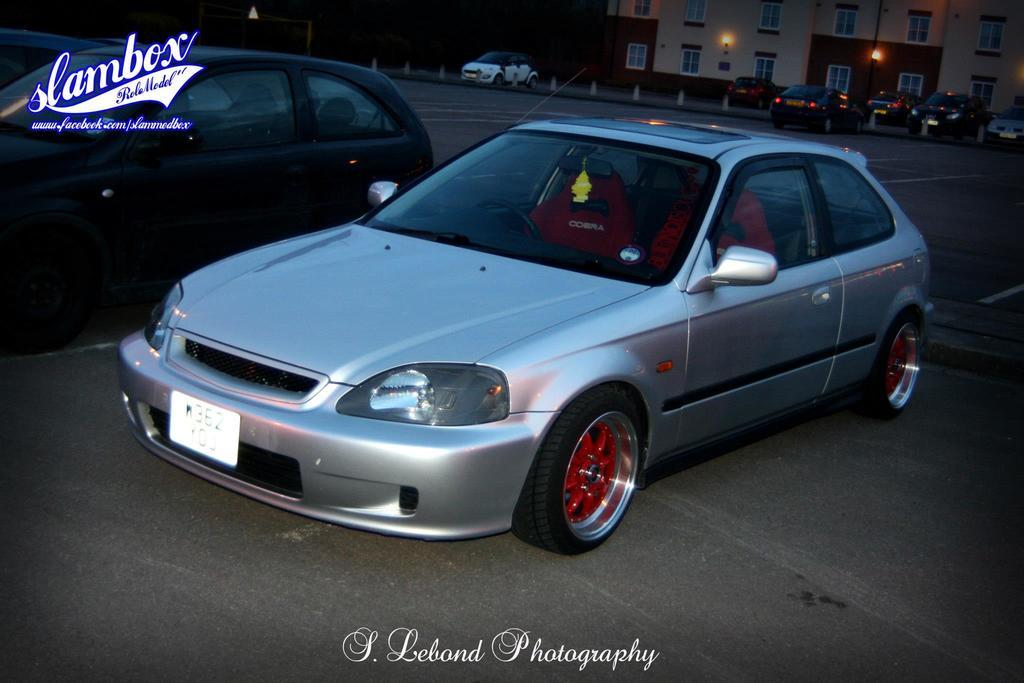What type of structures can be seen in the image? There are buildings in the image. What vehicles are present in the image? There are cars parked in the image. What can be seen illuminating the scene in the image? There are lights visible in the image. Where can text be found in the image? There is text at the top left corner and at the bottom of the image. What type of jeans are the bears wearing in the image? There are no bears or jeans present in the image. What is the range of the image? The range of the image cannot be determined from the provided facts, as it does not mention any distance or scope. 